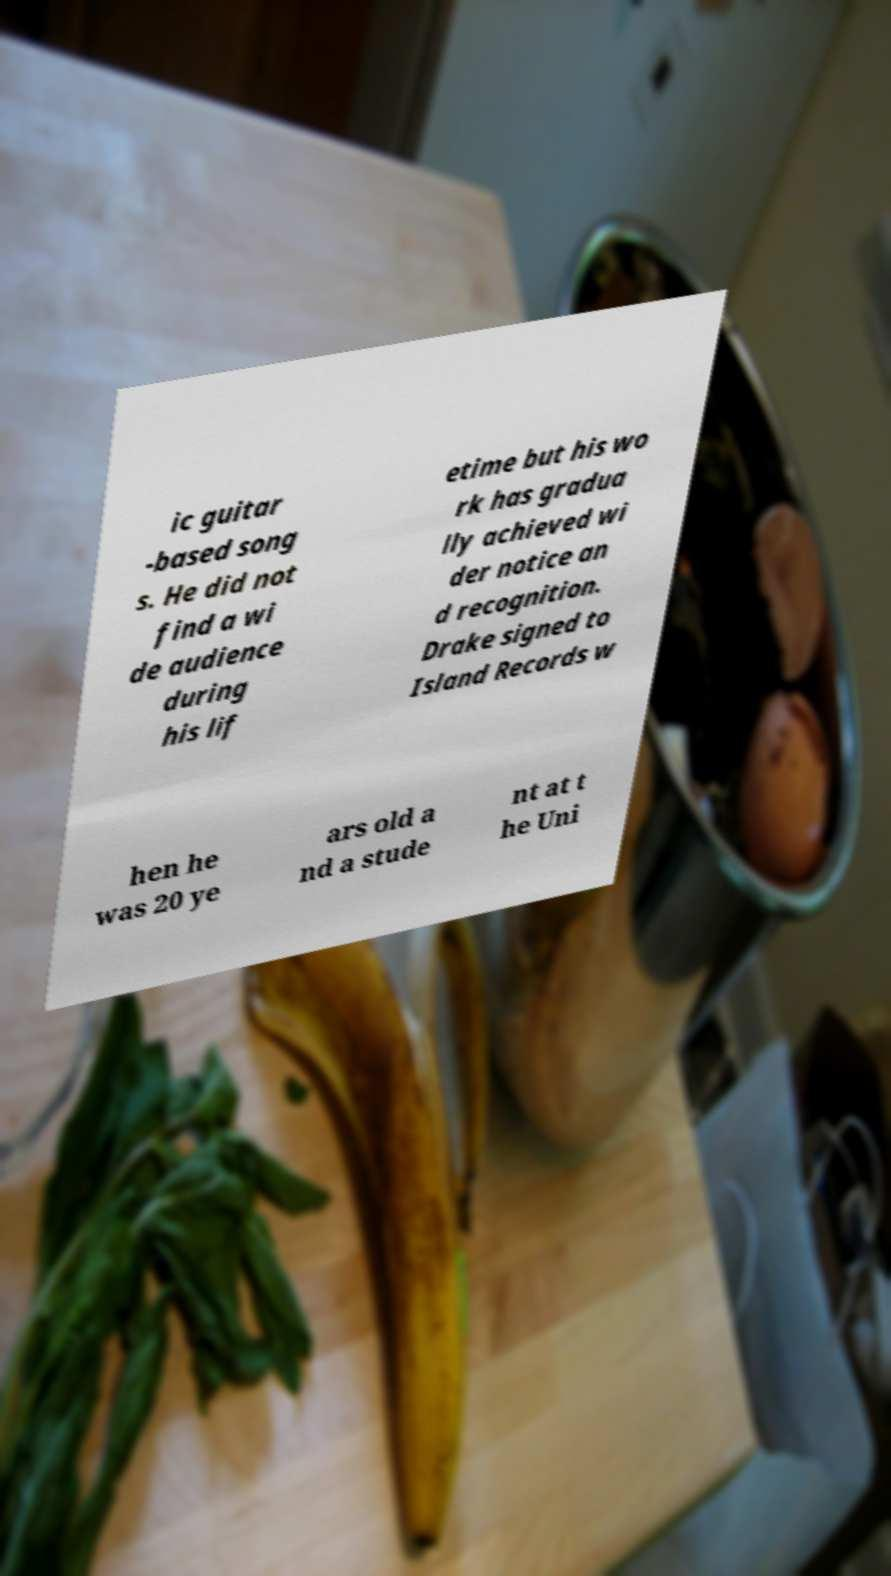I need the written content from this picture converted into text. Can you do that? ic guitar -based song s. He did not find a wi de audience during his lif etime but his wo rk has gradua lly achieved wi der notice an d recognition. Drake signed to Island Records w hen he was 20 ye ars old a nd a stude nt at t he Uni 